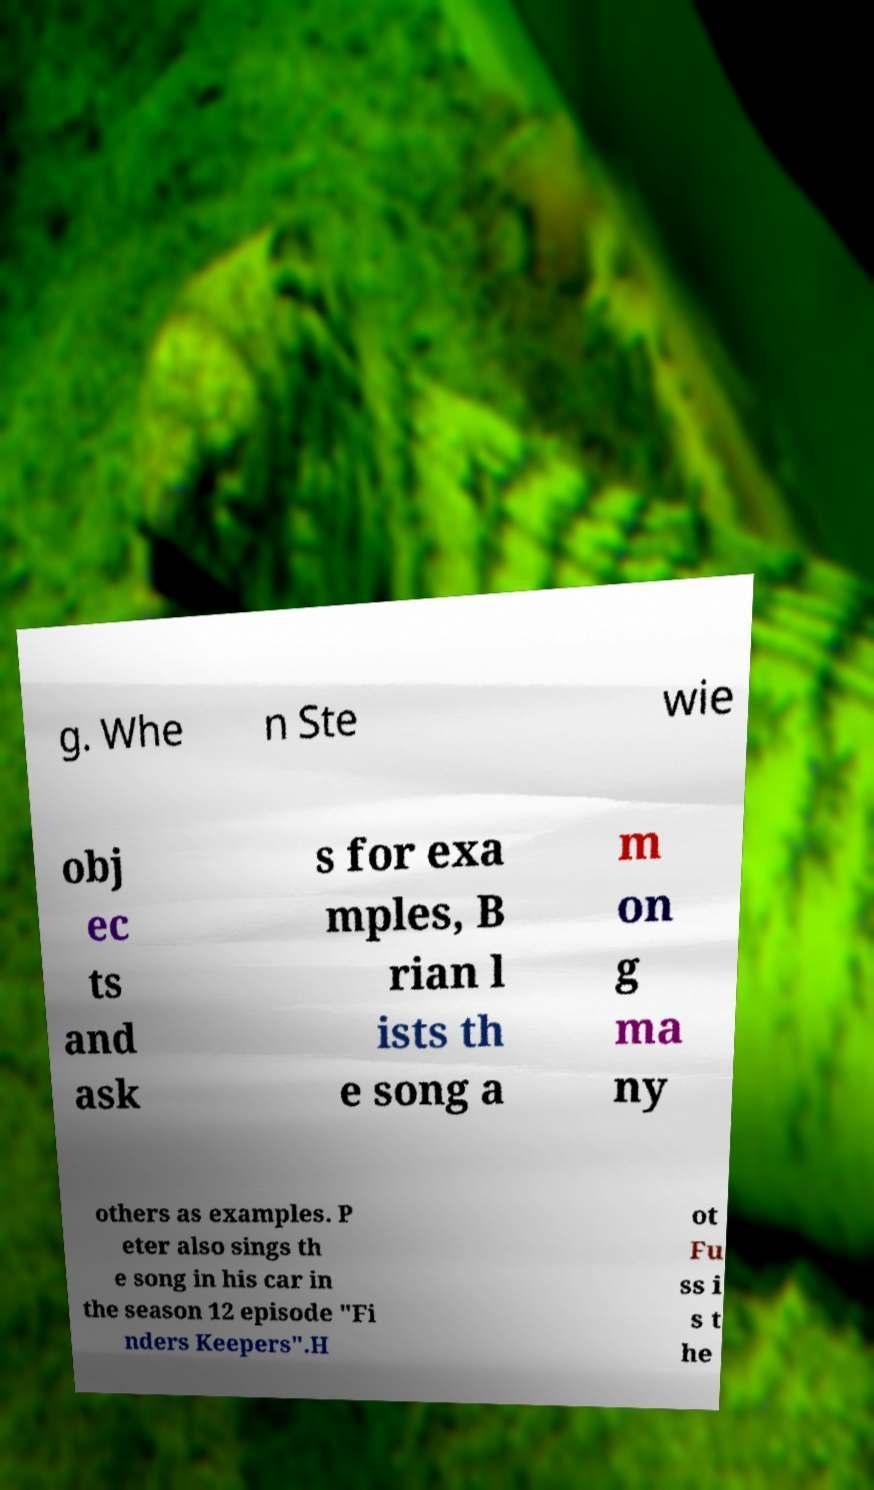Could you extract and type out the text from this image? g. Whe n Ste wie obj ec ts and ask s for exa mples, B rian l ists th e song a m on g ma ny others as examples. P eter also sings th e song in his car in the season 12 episode "Fi nders Keepers".H ot Fu ss i s t he 